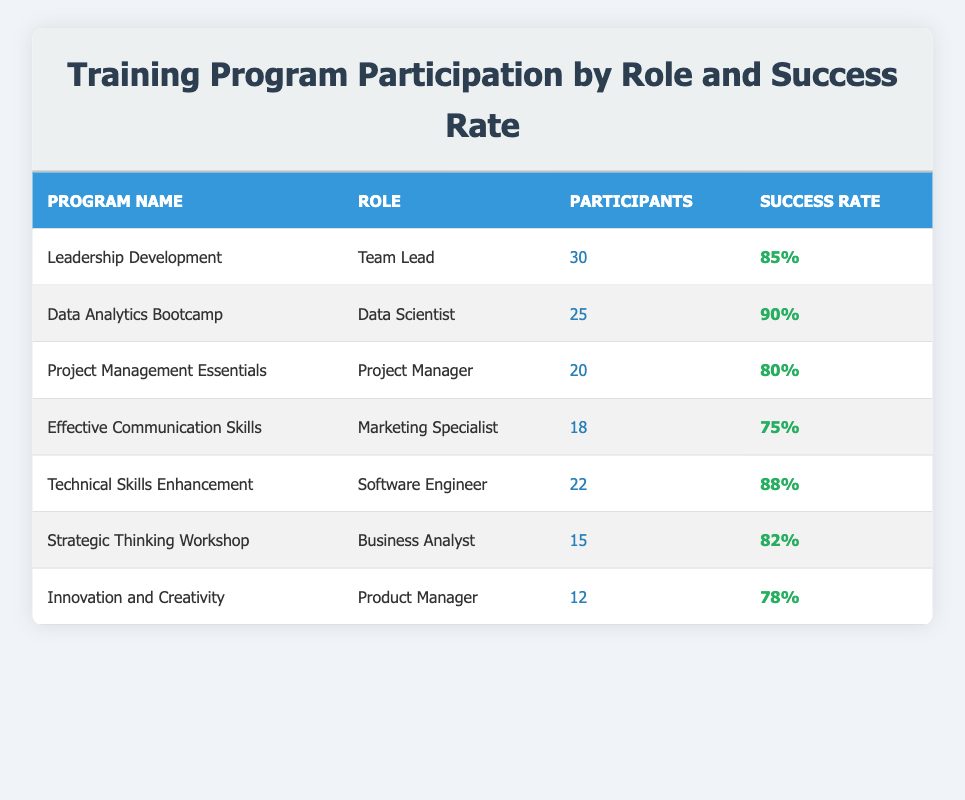What is the success rate of the Data Analytics Bootcamp? The success rate is listed directly in the row under the program name "Data Analytics Bootcamp," which shows a success rate of 90%.
Answer: 90% Which role has the highest number of participants? The table shows that the "Team Lead" role has the highest number of participants at 30, compared to other roles listed.
Answer: Team Lead What is the average success rate of all the training programs? To find the average success rate, sum all the success rates: (85 + 90 + 80 + 75 + 88 + 82 + 78) = 588; then divide by the number of programs (7), resulting in an average of 588/7 = 84.
Answer: 84 Does the Marketing Specialist role have a success rate above 80%? The success rate for the Marketing Specialist (75%) is below 80%, so the answer is no.
Answer: No In total, how many participants attended the Technical Skills Enhancement and Project Management Essentials programs combined? Adding the participants from both programs: 22 (Technical Skills Enhancement) + 20 (Project Management Essentials) = 42 participants in total.
Answer: 42 Which role has a success rate of less than 80%? The table lists the Product Manager role with a success rate of 78%, which is less than 80%.
Answer: Product Manager What is the difference in success rates between the highest and lowest programs? Identifying the highest success rate (90% from Data Analytics Bootcamp) and the lowest success rate (75% from Effective Communication Skills), the difference is 90% - 75% = 15%.
Answer: 15% 